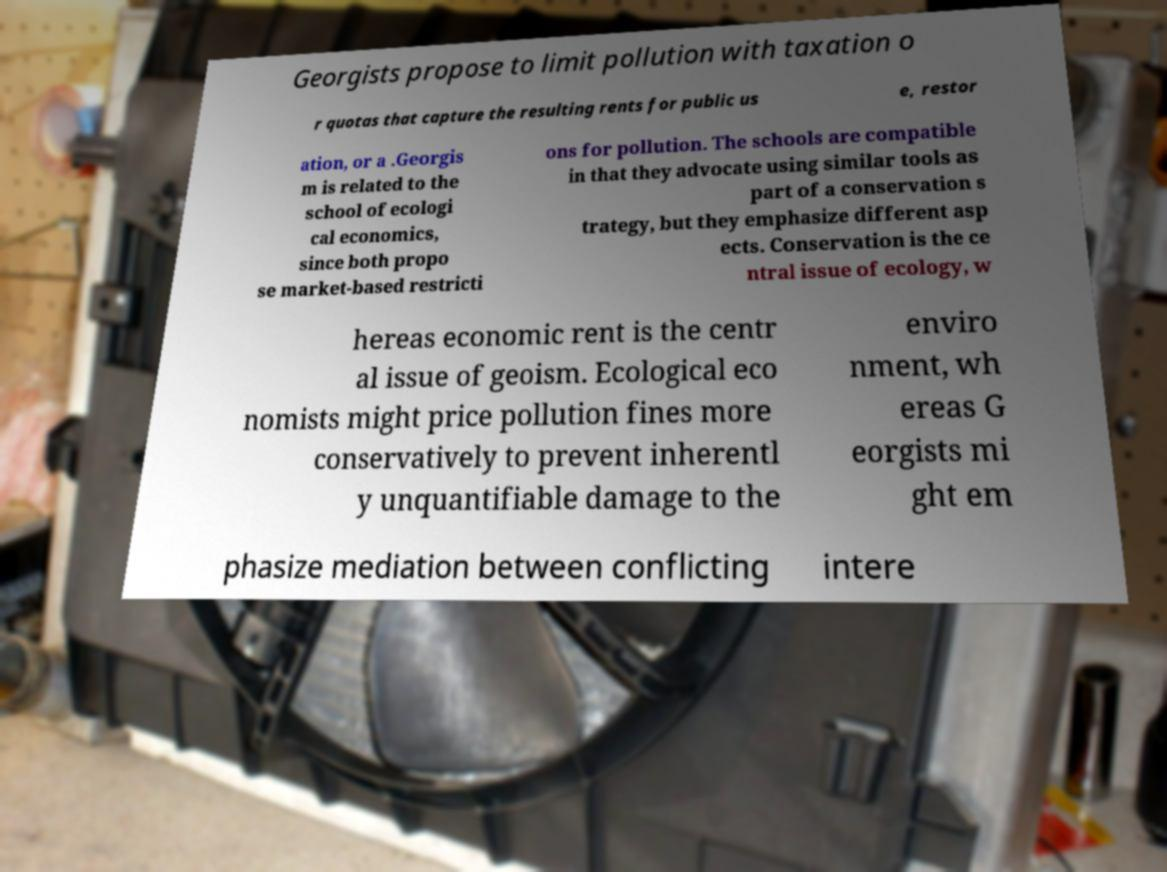I need the written content from this picture converted into text. Can you do that? Georgists propose to limit pollution with taxation o r quotas that capture the resulting rents for public us e, restor ation, or a .Georgis m is related to the school of ecologi cal economics, since both propo se market-based restricti ons for pollution. The schools are compatible in that they advocate using similar tools as part of a conservation s trategy, but they emphasize different asp ects. Conservation is the ce ntral issue of ecology, w hereas economic rent is the centr al issue of geoism. Ecological eco nomists might price pollution fines more conservatively to prevent inherentl y unquantifiable damage to the enviro nment, wh ereas G eorgists mi ght em phasize mediation between conflicting intere 